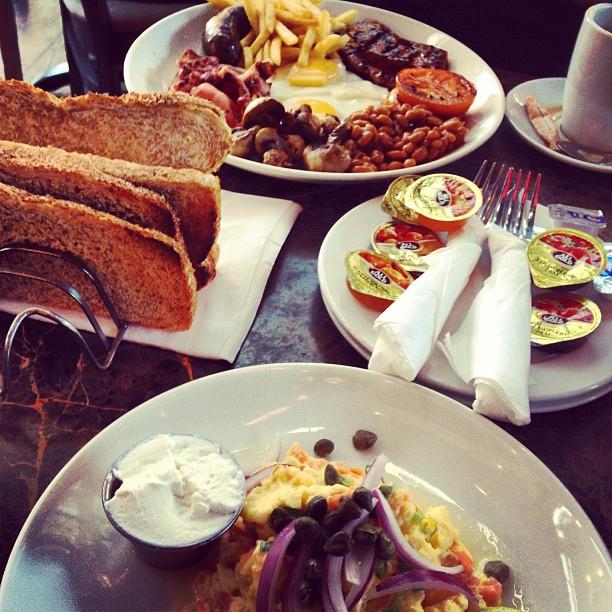Is there a hand in the picture?
Give a very brief answer. No. Is there two spoons in this picture?
Be succinct. No. Is anything neon green?
Quick response, please. No. Is this likely ethnic food?
Concise answer only. Yes. How many pieces of bread are on the table?
Give a very brief answer. 4. 